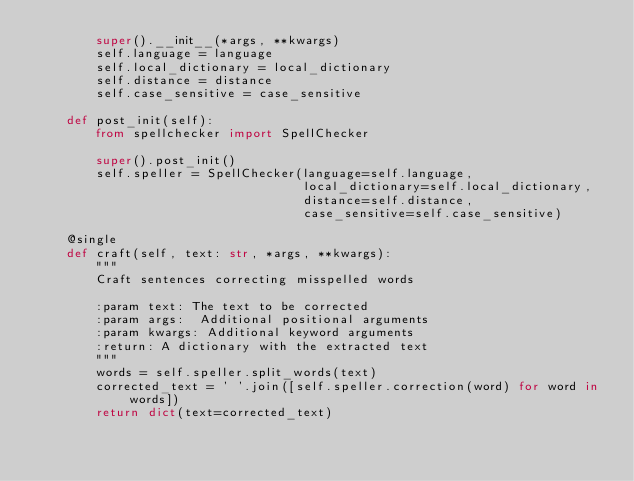Convert code to text. <code><loc_0><loc_0><loc_500><loc_500><_Python_>        super().__init__(*args, **kwargs)
        self.language = language
        self.local_dictionary = local_dictionary
        self.distance = distance
        self.case_sensitive = case_sensitive

    def post_init(self):
        from spellchecker import SpellChecker

        super().post_init()
        self.speller = SpellChecker(language=self.language,
                                    local_dictionary=self.local_dictionary,
                                    distance=self.distance,
                                    case_sensitive=self.case_sensitive)

    @single
    def craft(self, text: str, *args, **kwargs):
        """
        Craft sentences correcting misspelled words

        :param text: The text to be corrected
        :param args:  Additional positional arguments
        :param kwargs: Additional keyword arguments
        :return: A dictionary with the extracted text
        """
        words = self.speller.split_words(text)
        corrected_text = ' '.join([self.speller.correction(word) for word in words])
        return dict(text=corrected_text)
</code> 